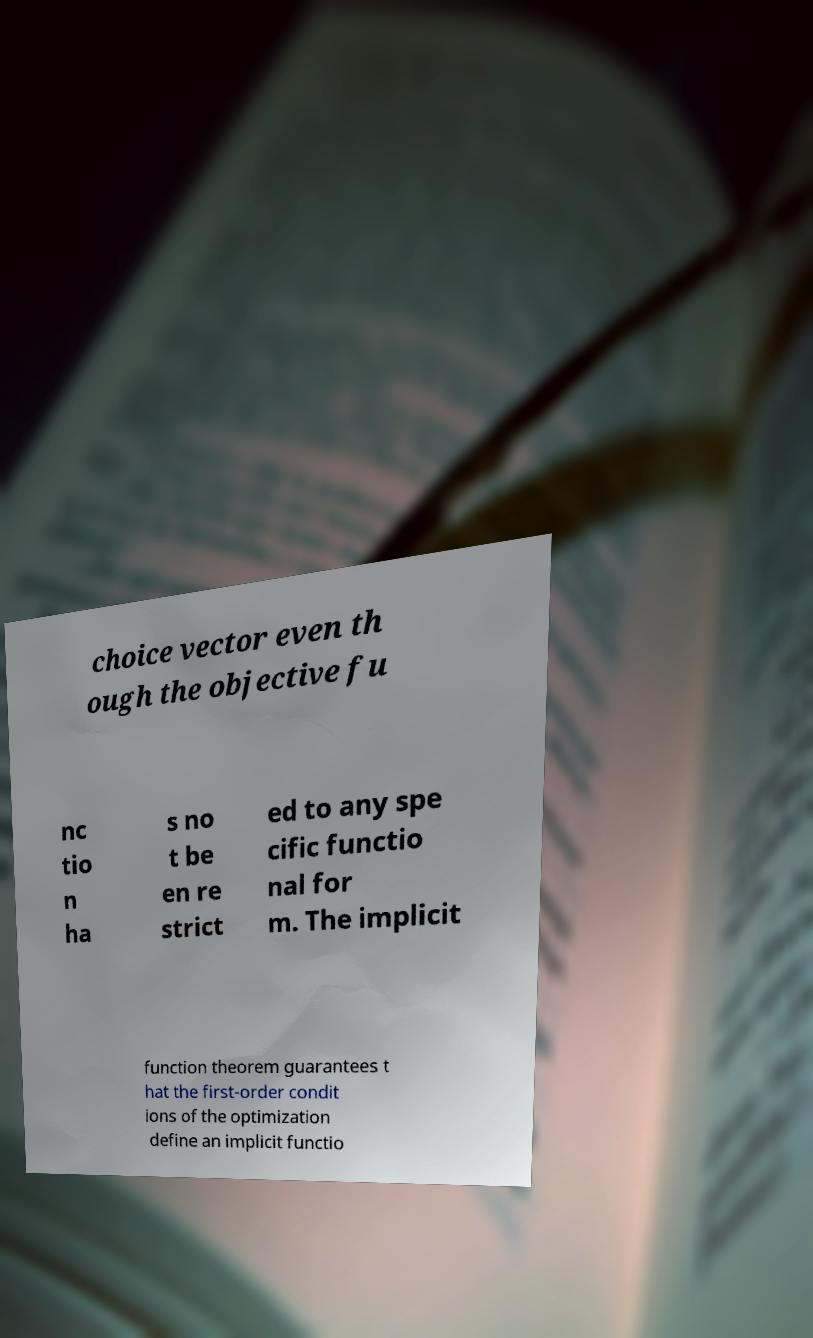There's text embedded in this image that I need extracted. Can you transcribe it verbatim? choice vector even th ough the objective fu nc tio n ha s no t be en re strict ed to any spe cific functio nal for m. The implicit function theorem guarantees t hat the first-order condit ions of the optimization define an implicit functio 